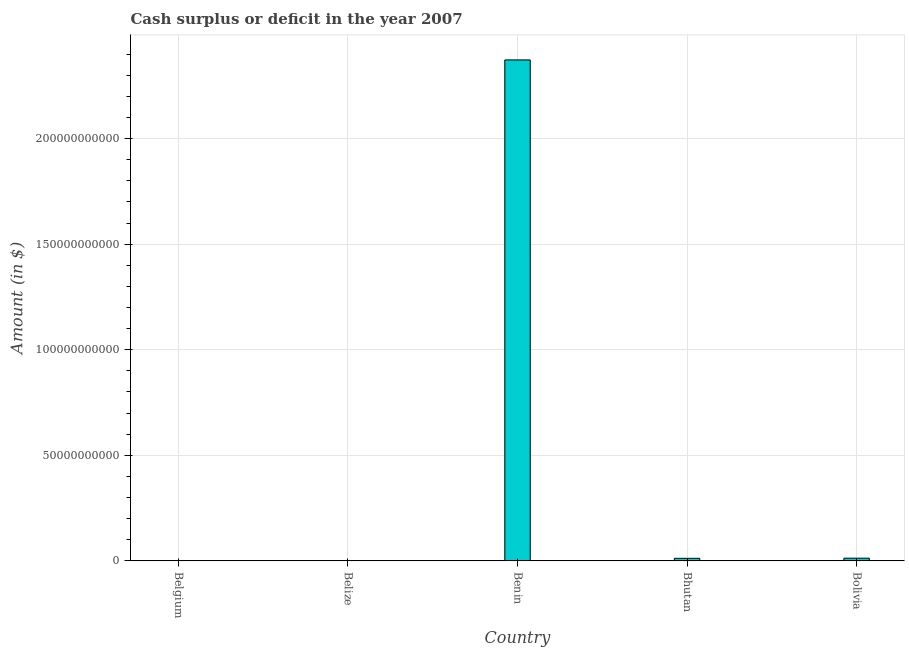Does the graph contain grids?
Give a very brief answer. Yes. What is the title of the graph?
Keep it short and to the point. Cash surplus or deficit in the year 2007. What is the label or title of the X-axis?
Provide a short and direct response. Country. What is the label or title of the Y-axis?
Offer a very short reply. Amount (in $). What is the cash surplus or deficit in Belize?
Provide a short and direct response. 0. Across all countries, what is the maximum cash surplus or deficit?
Give a very brief answer. 2.37e+11. Across all countries, what is the minimum cash surplus or deficit?
Keep it short and to the point. 0. In which country was the cash surplus or deficit maximum?
Your answer should be compact. Benin. What is the sum of the cash surplus or deficit?
Ensure brevity in your answer.  2.40e+11. What is the difference between the cash surplus or deficit in Benin and Bolivia?
Keep it short and to the point. 2.36e+11. What is the average cash surplus or deficit per country?
Provide a succinct answer. 4.80e+1. What is the median cash surplus or deficit?
Your answer should be compact. 1.22e+09. What is the ratio of the cash surplus or deficit in Benin to that in Bhutan?
Offer a terse response. 194.85. Is the difference between the cash surplus or deficit in Bhutan and Bolivia greater than the difference between any two countries?
Offer a terse response. No. What is the difference between the highest and the second highest cash surplus or deficit?
Give a very brief answer. 2.36e+11. What is the difference between the highest and the lowest cash surplus or deficit?
Your answer should be compact. 2.37e+11. Are all the bars in the graph horizontal?
Offer a terse response. No. Are the values on the major ticks of Y-axis written in scientific E-notation?
Ensure brevity in your answer.  No. What is the Amount (in $) in Benin?
Offer a terse response. 2.37e+11. What is the Amount (in $) in Bhutan?
Keep it short and to the point. 1.22e+09. What is the Amount (in $) of Bolivia?
Keep it short and to the point. 1.28e+09. What is the difference between the Amount (in $) in Benin and Bhutan?
Your response must be concise. 2.36e+11. What is the difference between the Amount (in $) in Benin and Bolivia?
Keep it short and to the point. 2.36e+11. What is the difference between the Amount (in $) in Bhutan and Bolivia?
Keep it short and to the point. -6.18e+07. What is the ratio of the Amount (in $) in Benin to that in Bhutan?
Make the answer very short. 194.85. What is the ratio of the Amount (in $) in Benin to that in Bolivia?
Your answer should be very brief. 185.44. 